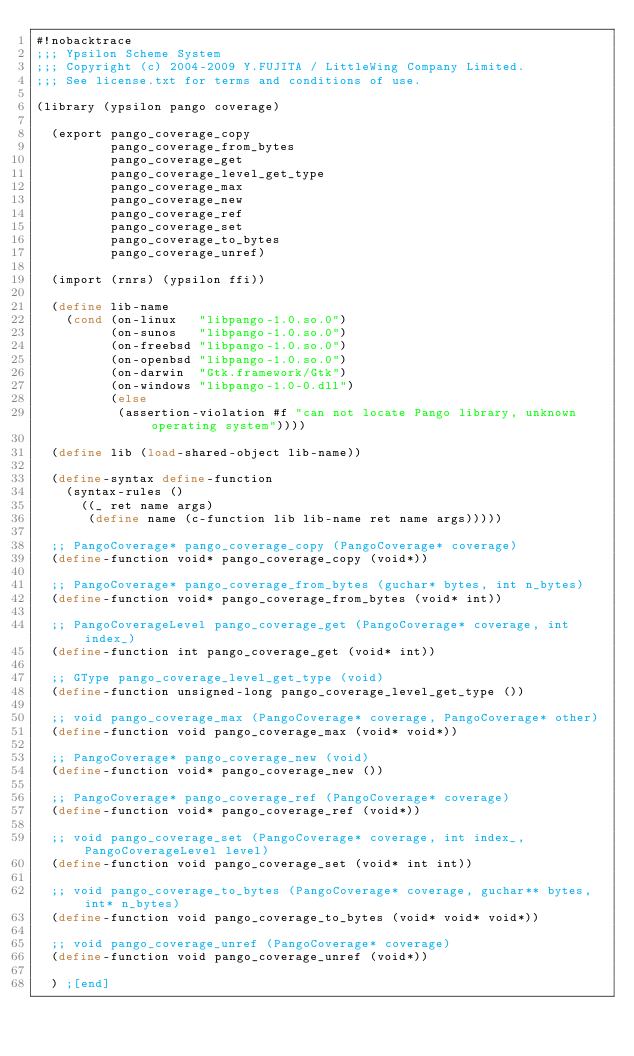<code> <loc_0><loc_0><loc_500><loc_500><_Scheme_>#!nobacktrace
;;; Ypsilon Scheme System
;;; Copyright (c) 2004-2009 Y.FUJITA / LittleWing Company Limited.
;;; See license.txt for terms and conditions of use.

(library (ypsilon pango coverage)

  (export pango_coverage_copy
          pango_coverage_from_bytes
          pango_coverage_get
          pango_coverage_level_get_type
          pango_coverage_max
          pango_coverage_new
          pango_coverage_ref
          pango_coverage_set
          pango_coverage_to_bytes
          pango_coverage_unref)

  (import (rnrs) (ypsilon ffi))

  (define lib-name
    (cond (on-linux   "libpango-1.0.so.0")
          (on-sunos   "libpango-1.0.so.0")
          (on-freebsd "libpango-1.0.so.0")
          (on-openbsd "libpango-1.0.so.0")
          (on-darwin  "Gtk.framework/Gtk")
          (on-windows "libpango-1.0-0.dll")
          (else
           (assertion-violation #f "can not locate Pango library, unknown operating system"))))

  (define lib (load-shared-object lib-name))

  (define-syntax define-function
    (syntax-rules ()
      ((_ ret name args)
       (define name (c-function lib lib-name ret name args)))))

  ;; PangoCoverage* pango_coverage_copy (PangoCoverage* coverage)
  (define-function void* pango_coverage_copy (void*))

  ;; PangoCoverage* pango_coverage_from_bytes (guchar* bytes, int n_bytes)
  (define-function void* pango_coverage_from_bytes (void* int))

  ;; PangoCoverageLevel pango_coverage_get (PangoCoverage* coverage, int index_)
  (define-function int pango_coverage_get (void* int))

  ;; GType pango_coverage_level_get_type (void)
  (define-function unsigned-long pango_coverage_level_get_type ())

  ;; void pango_coverage_max (PangoCoverage* coverage, PangoCoverage* other)
  (define-function void pango_coverage_max (void* void*))

  ;; PangoCoverage* pango_coverage_new (void)
  (define-function void* pango_coverage_new ())

  ;; PangoCoverage* pango_coverage_ref (PangoCoverage* coverage)
  (define-function void* pango_coverage_ref (void*))

  ;; void pango_coverage_set (PangoCoverage* coverage, int index_, PangoCoverageLevel level)
  (define-function void pango_coverage_set (void* int int))

  ;; void pango_coverage_to_bytes (PangoCoverage* coverage, guchar** bytes, int* n_bytes)
  (define-function void pango_coverage_to_bytes (void* void* void*))

  ;; void pango_coverage_unref (PangoCoverage* coverage)
  (define-function void pango_coverage_unref (void*))

  ) ;[end]
</code> 